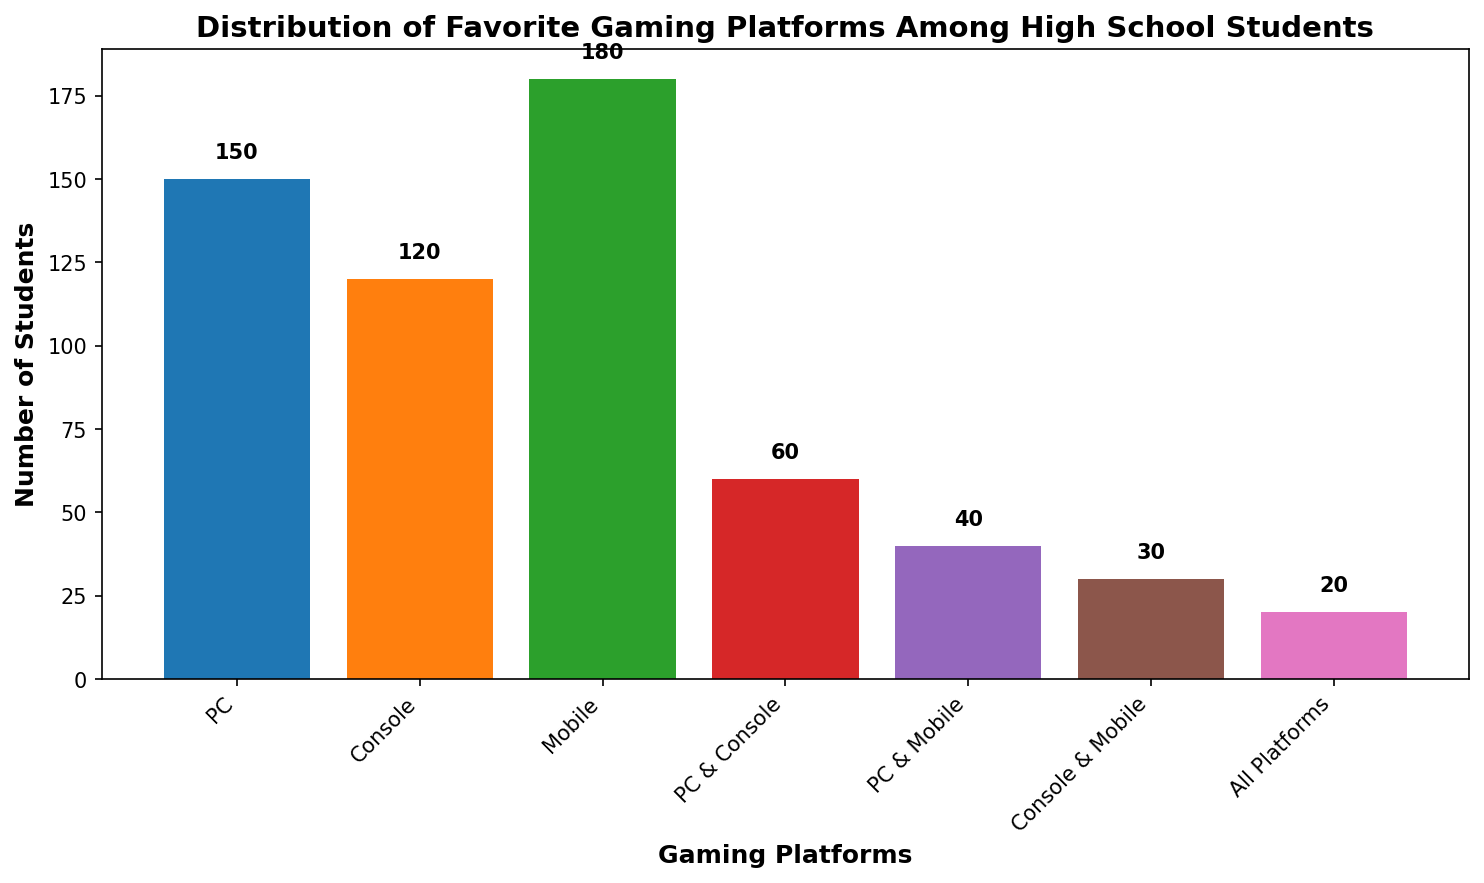What's the most popular gaming platform among high school students? The tallest bar in the bar chart represents the most popular gaming platform. The tallest bar corresponds to "Mobile" with a count of 180 students.
Answer: Mobile Which combined platform is more popular, "PC & Console" or "Console & Mobile"? To find out, compare the heights (counts) of the bars for "PC & Console" and "Console & Mobile". The "PC & Console" bar has a count of 60, while the "Console & Mobile" bar has a count of 30. Therefore, "PC & Console" is more popular.
Answer: PC & Console How many students prefer using only the PC as their favorite gaming platform? Look for the bar labeled "PC" and read the count value at the top of the bar. The count for "PC" is 150 students.
Answer: 150 What's the total number of students who prefer any combination of platforms (PC & Console, PC & Mobile, Console & Mobile, All Platforms)? Sum up the counts of the bars corresponding to "PC & Console", "PC & Mobile", "Console & Mobile", and "All Platforms". That is 60 (PC & Console) + 40 (PC & Mobile) + 30 (Console & Mobile) + 20 (All Platforms) = 150 students.
Answer: 150 Compare the popularity between students who prefer "PC" only and those who prefer all three platforms ("All Platforms"). Which category has more students? Compare the heights (counts) of the "PC" bar and the "All Platforms" bar. The "PC" bar has a count of 150, whereas the "All Platforms" bar has a count of 20. "PC" only has more students.
Answer: PC What's the difference in the number of students between the most popular platform and the least popular combination? Identify the counts for the most popular platform (Mobile: 180) and the least popular combination (All Platforms: 20). Subtract the smaller count from the larger: 180 - 20 = 160 students.
Answer: 160 How many students prefer either "Console" only or "Console & Mobile"? Sum the counts of the bars labeled "Console" and "Console & Mobile". That is 120 (Console) + 30 (Console & Mobile) = 150 students.
Answer: 150 Which platform or combination of platforms has a count of 60 students? Find the bar with the height corresponding to 60 students. The bar labeled "PC & Console" has a count of 60.
Answer: PC & Console What's the total number of students surveyed? Sum up the counts of all the bars to get the total number of students. That is 150 + 120 + 180 + 60 + 40 + 30 + 20 = 600 students.
Answer: 600 